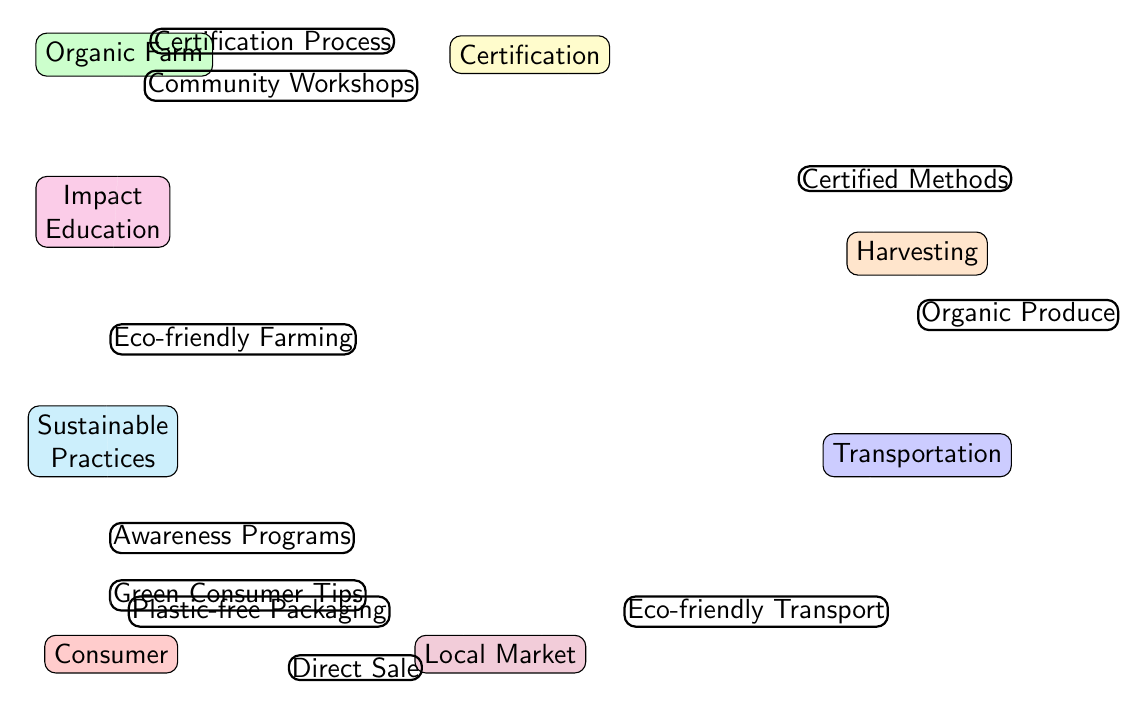What is the first node in the food chain? The starting point of the chain is the "Organic Farm," which is the initial source of organic produce.
Answer: Organic Farm How many edges are connected to the Local Market? The Local Market has two edges connected to it, one from Transportation and one from Sustainable Practices.
Answer: 2 What process certifies the organic methods used at the farm? The "Certification Process" is the step that ensures the methods used by the farm meet organic standards.
Answer: Certification Process Which node represents the actions taken after produce is harvested? The node that follows harvesting in the diagram is "Transportation," which indicates the movement of organic produce to the market.
Answer: Transportation What flow connects the Sustainable Practices to the Consumer? There are two flows leading from Sustainable Practices to the Consumer: one representing "Green Consumer Tips" and another from "Plastic-free Packaging" through Local Market.
Answer: 2 How does the Organic Farm directly promote awareness? The farm promotes awareness through "Community Workshops," which are designed to educate the community about organic practices.
Answer: Community Workshops What role does the Certifying Body play in the journey of organic produce? The Certifying Body is responsible for ensuring that organic methods used by the farm comply with certification standards for organic produce.
Answer: Certification What kind of educational efforts are indicated in the diagram? The diagram indicates "Impact Education" through "Awareness Programs" that aim to educate consumers about sustainable practices.
Answer: Awareness Programs What is the final destination of organic produce in this food chain? The final destination of the organic produce is the "Consumer," who purchases and uses the organic products.
Answer: Consumer Which aspect of transportation is highlighted in the diagram? The diagram emphasizes "Eco-friendly Transport," which is the method of moving organic produce while minimizing environmental impact.
Answer: Eco-friendly Transport 